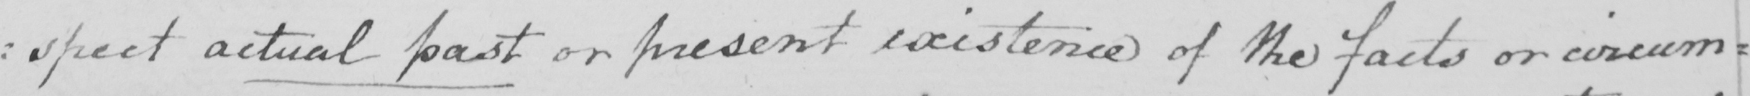What does this handwritten line say? : spect actual past or present existence of the facts or circum= 